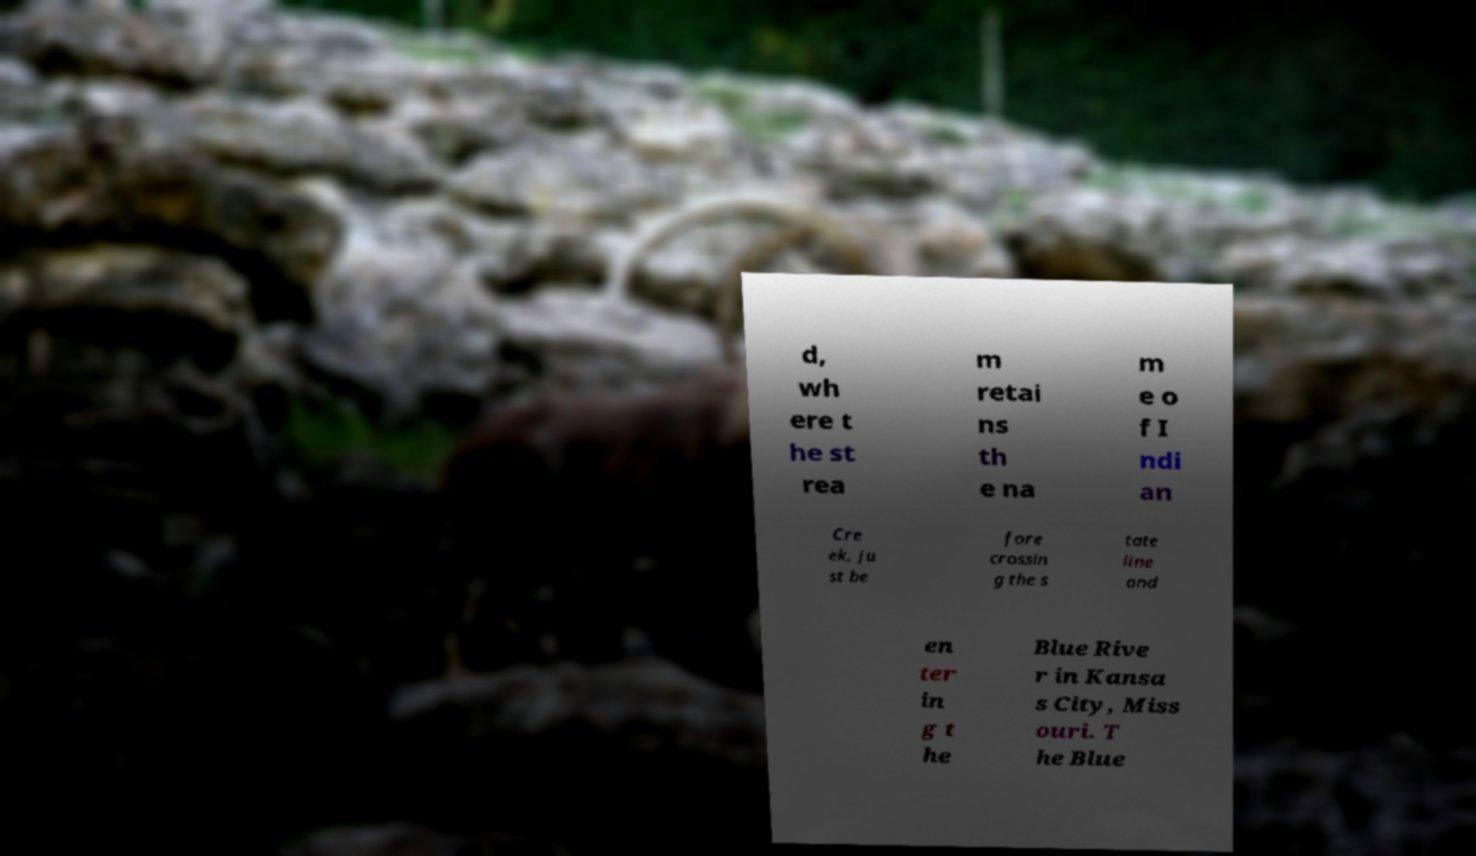Can you read and provide the text displayed in the image?This photo seems to have some interesting text. Can you extract and type it out for me? d, wh ere t he st rea m retai ns th e na m e o f I ndi an Cre ek, ju st be fore crossin g the s tate line and en ter in g t he Blue Rive r in Kansa s City, Miss ouri. T he Blue 